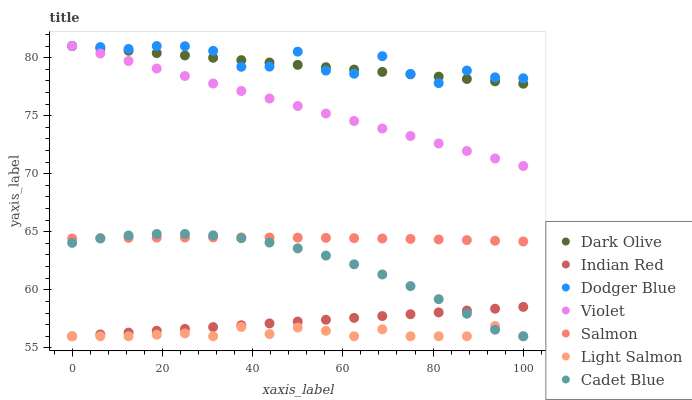Does Light Salmon have the minimum area under the curve?
Answer yes or no. Yes. Does Dodger Blue have the maximum area under the curve?
Answer yes or no. Yes. Does Cadet Blue have the minimum area under the curve?
Answer yes or no. No. Does Cadet Blue have the maximum area under the curve?
Answer yes or no. No. Is Indian Red the smoothest?
Answer yes or no. Yes. Is Dodger Blue the roughest?
Answer yes or no. Yes. Is Cadet Blue the smoothest?
Answer yes or no. No. Is Cadet Blue the roughest?
Answer yes or no. No. Does Light Salmon have the lowest value?
Answer yes or no. Yes. Does Dark Olive have the lowest value?
Answer yes or no. No. Does Violet have the highest value?
Answer yes or no. Yes. Does Cadet Blue have the highest value?
Answer yes or no. No. Is Light Salmon less than Salmon?
Answer yes or no. Yes. Is Dark Olive greater than Light Salmon?
Answer yes or no. Yes. Does Cadet Blue intersect Light Salmon?
Answer yes or no. Yes. Is Cadet Blue less than Light Salmon?
Answer yes or no. No. Is Cadet Blue greater than Light Salmon?
Answer yes or no. No. Does Light Salmon intersect Salmon?
Answer yes or no. No. 